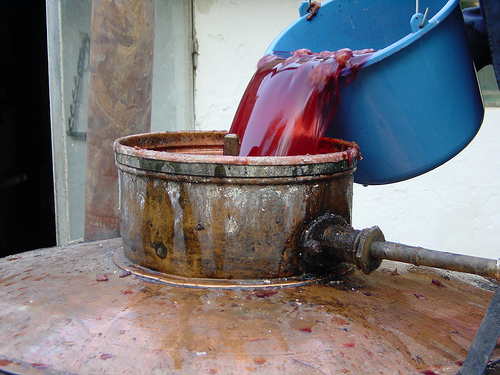<image>
Is the wine in the bucket? Yes. The wine is contained within or inside the bucket, showing a containment relationship. 